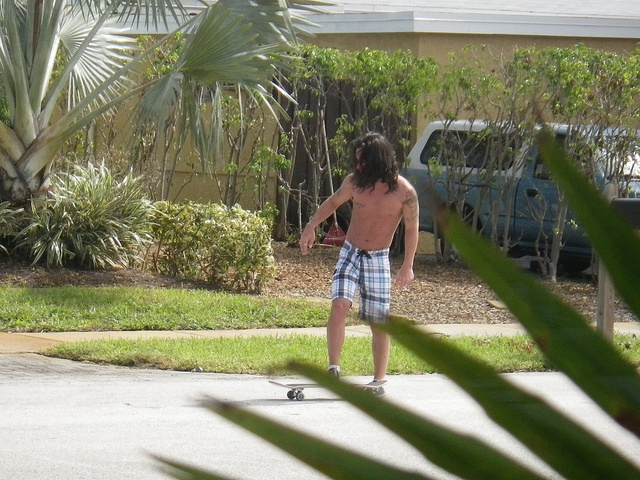Describe the objects in this image and their specific colors. I can see truck in gray, black, and darkgreen tones, people in gray, brown, black, and darkgray tones, and skateboard in gray, lightgray, and darkgray tones in this image. 